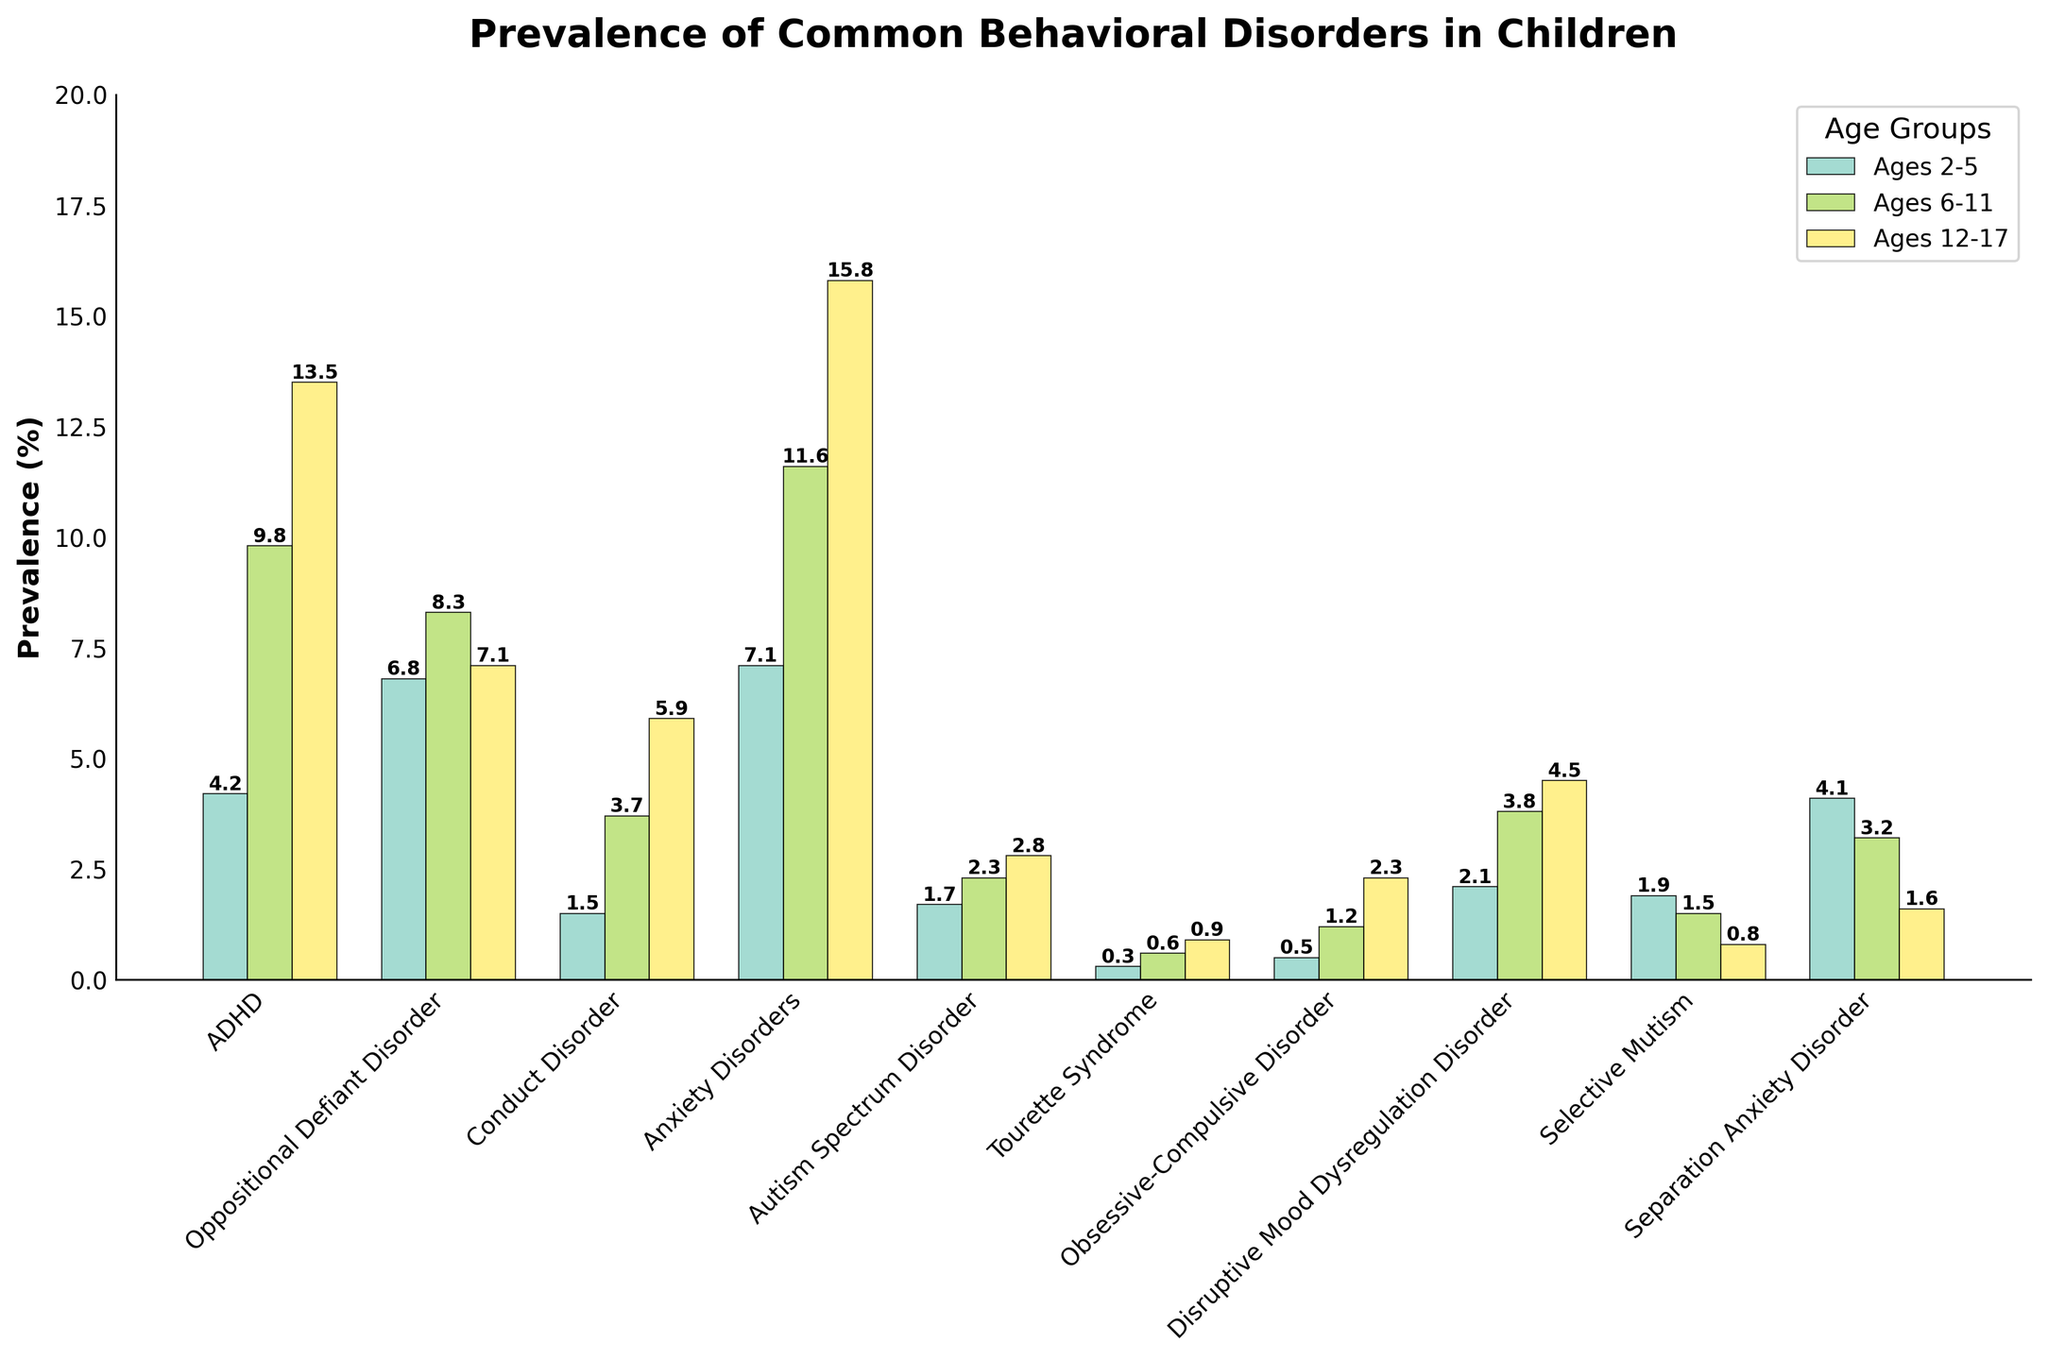What disorder has the highest prevalence among children aged 12-17? By examining the bars representing children aged 12-17, we can see that Anxiety Disorders have the highest bar, indicating the highest prevalence.
Answer: Anxiety Disorders Which age group has the lowest prevalence of Tourette Syndrome? The plot shows three bars for Tourette Syndrome, and the shortest bar corresponds to ages 2-5.
Answer: Ages 2-5 Compare the prevalence of Oppositional Defiant Disorder in ages 6-11 and ages 12-17. Which is higher? By comparing the heights of the bars for Oppositional Defiant Disorder, the bar for ages 6-11 is slightly higher than the bar for ages 12-17.
Answer: Ages 6-11 What is the sum of the prevalence rates of ADHD for all age groups? The prevalence rates for ADHD are 4.2 (ages 2-5), 9.8 (ages 6-11), and 13.5 (ages 12-17). Adding them together: 4.2 + 9.8 + 13.5 = 27.5.
Answer: 27.5 Which disorder has the greatest difference in prevalence between ages 2-5 and ages 12-17? By comparing the differences in bar heights between ages 2-5 and ages 12-17, Anxiety Disorders have the greatest difference, which is 15.8 - 7.1 = 8.7.
Answer: Anxiety Disorders Which behavioral disorder decreases in prevalence as children get older? The bar heights for Selective Mutism decrease with age, with the tallest bar for ages 2-5, a smaller bar for ages 6-11, and the smallest bar for ages 12-17.
Answer: Selective Mutism What is the average prevalence rate of Autism Spectrum Disorder across all age groups? The prevalence rates for Autism Spectrum Disorder are 1.7, 2.3, and 2.8. Adding them and dividing by 3: (1.7 + 2.3 + 2.8)/3 = 2.27.
Answer: 2.27 Is the prevalence of Separation Anxiety Disorder higher in ages 6-11 or ages 2-5? Comparing the bar heights for Separation Anxiety Disorder shows that the bar for ages 2-5 is higher than that for ages 6-11.
Answer: Ages 2-5 What is the prevalence of Conduct Disorder among children aged 6-11? By looking at the bar for Conduct Disorder in the ages 6-11 group, we can see it is 3.7.
Answer: 3.7 Which disorder has the second-highest prevalence among children aged 2-5? Among ages 2-5, the second highest bar after Anxiety Disorders (7.1) is for Oppositional Defiant Disorder (6.8).
Answer: Oppositional Defiant Disorder 